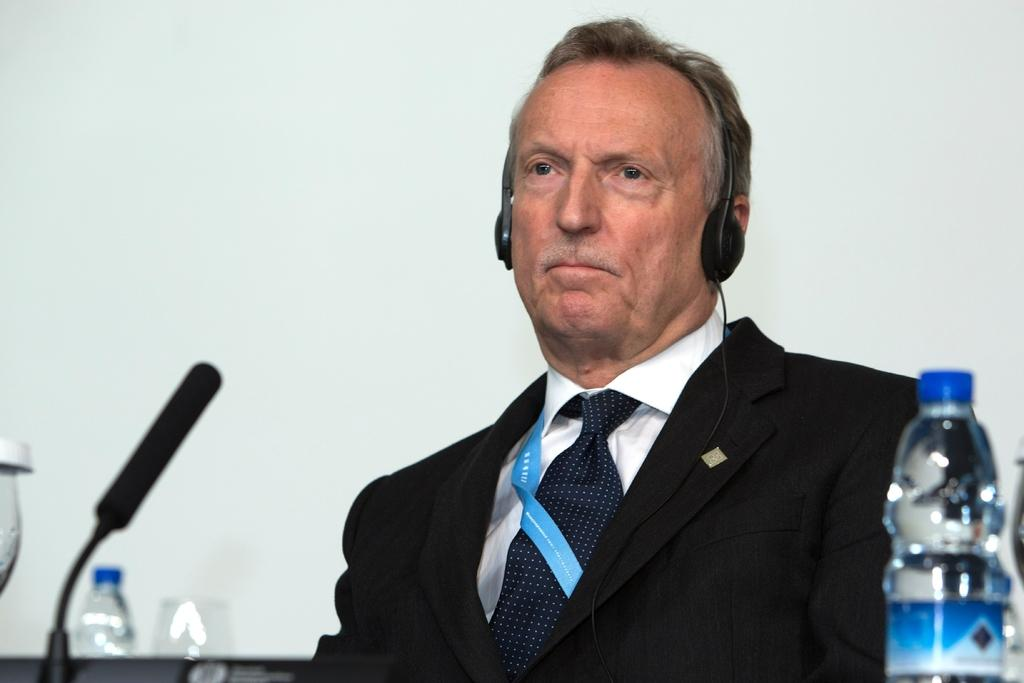What is the person in the image doing? The person is sitting on a chair in the image. What is the person wearing on their head? The person is wearing a headset in the image. What object is in front of the person? There is a microphone in front of the person in the image. What item is also present in front of the person? There is a water bottle in front of the person in the image. What type of box is the person using to cause a behavioral change in the image? There is no box or behavioral change mentioned in the image. The image only shows a person sitting on a chair with a headset, a microphone, and a water bottle in front of them. 